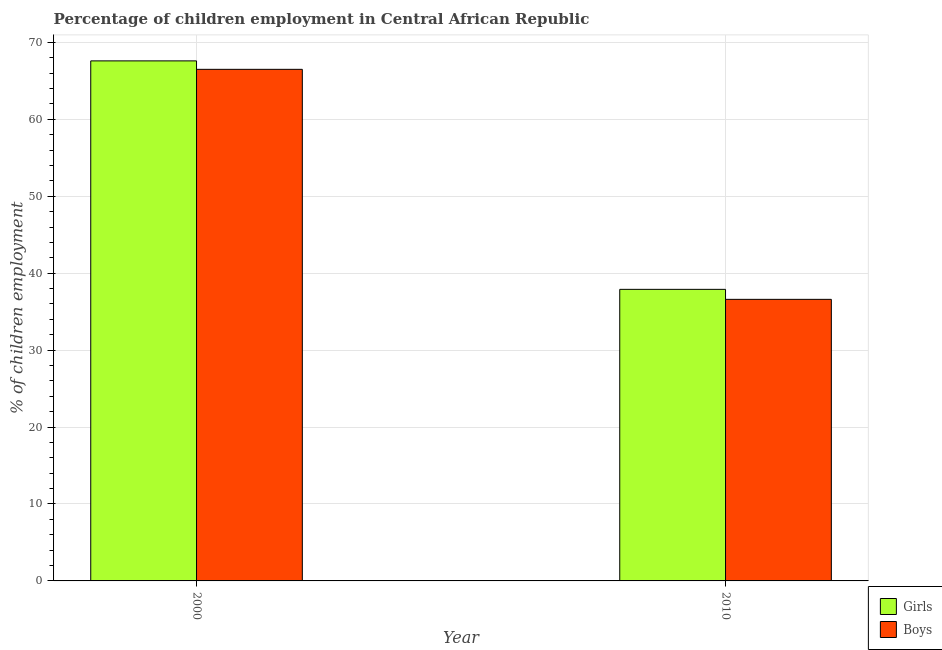Are the number of bars per tick equal to the number of legend labels?
Offer a terse response. Yes. Are the number of bars on each tick of the X-axis equal?
Keep it short and to the point. Yes. In how many cases, is the number of bars for a given year not equal to the number of legend labels?
Your response must be concise. 0. What is the percentage of employed boys in 2000?
Your response must be concise. 66.5. Across all years, what is the maximum percentage of employed boys?
Provide a succinct answer. 66.5. Across all years, what is the minimum percentage of employed boys?
Your answer should be very brief. 36.6. What is the total percentage of employed boys in the graph?
Make the answer very short. 103.1. What is the difference between the percentage of employed girls in 2000 and that in 2010?
Make the answer very short. 29.7. What is the difference between the percentage of employed girls in 2010 and the percentage of employed boys in 2000?
Provide a short and direct response. -29.7. What is the average percentage of employed boys per year?
Give a very brief answer. 51.55. In the year 2010, what is the difference between the percentage of employed girls and percentage of employed boys?
Offer a very short reply. 0. In how many years, is the percentage of employed girls greater than 66 %?
Provide a short and direct response. 1. What is the ratio of the percentage of employed boys in 2000 to that in 2010?
Provide a short and direct response. 1.82. Is the percentage of employed boys in 2000 less than that in 2010?
Your response must be concise. No. In how many years, is the percentage of employed girls greater than the average percentage of employed girls taken over all years?
Give a very brief answer. 1. What does the 2nd bar from the left in 2000 represents?
Ensure brevity in your answer.  Boys. What does the 1st bar from the right in 2010 represents?
Provide a succinct answer. Boys. Are the values on the major ticks of Y-axis written in scientific E-notation?
Provide a short and direct response. No. Does the graph contain any zero values?
Make the answer very short. No. Where does the legend appear in the graph?
Your answer should be very brief. Bottom right. What is the title of the graph?
Keep it short and to the point. Percentage of children employment in Central African Republic. What is the label or title of the Y-axis?
Make the answer very short. % of children employment. What is the % of children employment in Girls in 2000?
Keep it short and to the point. 67.6. What is the % of children employment in Boys in 2000?
Ensure brevity in your answer.  66.5. What is the % of children employment in Girls in 2010?
Keep it short and to the point. 37.9. What is the % of children employment of Boys in 2010?
Your answer should be compact. 36.6. Across all years, what is the maximum % of children employment of Girls?
Make the answer very short. 67.6. Across all years, what is the maximum % of children employment in Boys?
Make the answer very short. 66.5. Across all years, what is the minimum % of children employment of Girls?
Your response must be concise. 37.9. Across all years, what is the minimum % of children employment of Boys?
Your answer should be compact. 36.6. What is the total % of children employment of Girls in the graph?
Keep it short and to the point. 105.5. What is the total % of children employment in Boys in the graph?
Provide a succinct answer. 103.1. What is the difference between the % of children employment in Girls in 2000 and that in 2010?
Provide a succinct answer. 29.7. What is the difference between the % of children employment in Boys in 2000 and that in 2010?
Your answer should be very brief. 29.9. What is the difference between the % of children employment in Girls in 2000 and the % of children employment in Boys in 2010?
Provide a short and direct response. 31. What is the average % of children employment of Girls per year?
Make the answer very short. 52.75. What is the average % of children employment in Boys per year?
Give a very brief answer. 51.55. In the year 2000, what is the difference between the % of children employment in Girls and % of children employment in Boys?
Ensure brevity in your answer.  1.1. What is the ratio of the % of children employment of Girls in 2000 to that in 2010?
Your response must be concise. 1.78. What is the ratio of the % of children employment of Boys in 2000 to that in 2010?
Your answer should be very brief. 1.82. What is the difference between the highest and the second highest % of children employment in Girls?
Provide a succinct answer. 29.7. What is the difference between the highest and the second highest % of children employment of Boys?
Offer a terse response. 29.9. What is the difference between the highest and the lowest % of children employment of Girls?
Your answer should be compact. 29.7. What is the difference between the highest and the lowest % of children employment of Boys?
Ensure brevity in your answer.  29.9. 